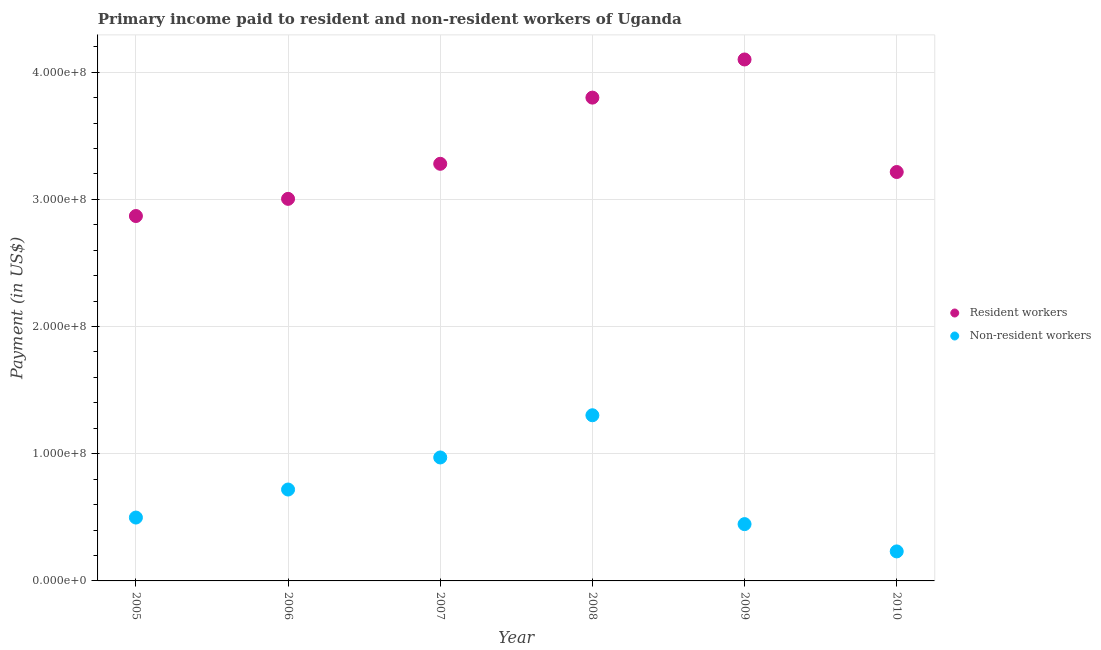How many different coloured dotlines are there?
Offer a terse response. 2. What is the payment made to resident workers in 2010?
Keep it short and to the point. 3.21e+08. Across all years, what is the maximum payment made to non-resident workers?
Give a very brief answer. 1.30e+08. Across all years, what is the minimum payment made to resident workers?
Provide a short and direct response. 2.87e+08. In which year was the payment made to resident workers maximum?
Offer a very short reply. 2009. In which year was the payment made to non-resident workers minimum?
Keep it short and to the point. 2010. What is the total payment made to resident workers in the graph?
Give a very brief answer. 2.03e+09. What is the difference between the payment made to resident workers in 2007 and that in 2009?
Your answer should be compact. -8.20e+07. What is the difference between the payment made to resident workers in 2010 and the payment made to non-resident workers in 2006?
Keep it short and to the point. 2.50e+08. What is the average payment made to resident workers per year?
Your answer should be compact. 3.38e+08. In the year 2009, what is the difference between the payment made to non-resident workers and payment made to resident workers?
Offer a terse response. -3.65e+08. What is the ratio of the payment made to non-resident workers in 2005 to that in 2006?
Your response must be concise. 0.69. What is the difference between the highest and the second highest payment made to resident workers?
Give a very brief answer. 3.00e+07. What is the difference between the highest and the lowest payment made to non-resident workers?
Give a very brief answer. 1.07e+08. In how many years, is the payment made to resident workers greater than the average payment made to resident workers taken over all years?
Your response must be concise. 2. How many years are there in the graph?
Your response must be concise. 6. What is the difference between two consecutive major ticks on the Y-axis?
Your answer should be very brief. 1.00e+08. Does the graph contain any zero values?
Ensure brevity in your answer.  No. Where does the legend appear in the graph?
Your answer should be very brief. Center right. How are the legend labels stacked?
Give a very brief answer. Vertical. What is the title of the graph?
Your answer should be compact. Primary income paid to resident and non-resident workers of Uganda. Does "Commercial bank branches" appear as one of the legend labels in the graph?
Offer a terse response. No. What is the label or title of the Y-axis?
Provide a short and direct response. Payment (in US$). What is the Payment (in US$) of Resident workers in 2005?
Provide a short and direct response. 2.87e+08. What is the Payment (in US$) of Non-resident workers in 2005?
Ensure brevity in your answer.  4.98e+07. What is the Payment (in US$) in Resident workers in 2006?
Make the answer very short. 3.00e+08. What is the Payment (in US$) of Non-resident workers in 2006?
Provide a short and direct response. 7.19e+07. What is the Payment (in US$) of Resident workers in 2007?
Make the answer very short. 3.28e+08. What is the Payment (in US$) in Non-resident workers in 2007?
Offer a very short reply. 9.71e+07. What is the Payment (in US$) of Resident workers in 2008?
Provide a short and direct response. 3.80e+08. What is the Payment (in US$) in Non-resident workers in 2008?
Ensure brevity in your answer.  1.30e+08. What is the Payment (in US$) in Resident workers in 2009?
Your answer should be very brief. 4.10e+08. What is the Payment (in US$) in Non-resident workers in 2009?
Offer a very short reply. 4.47e+07. What is the Payment (in US$) of Resident workers in 2010?
Ensure brevity in your answer.  3.21e+08. What is the Payment (in US$) in Non-resident workers in 2010?
Keep it short and to the point. 2.32e+07. Across all years, what is the maximum Payment (in US$) in Resident workers?
Keep it short and to the point. 4.10e+08. Across all years, what is the maximum Payment (in US$) of Non-resident workers?
Offer a very short reply. 1.30e+08. Across all years, what is the minimum Payment (in US$) of Resident workers?
Your answer should be very brief. 2.87e+08. Across all years, what is the minimum Payment (in US$) in Non-resident workers?
Ensure brevity in your answer.  2.32e+07. What is the total Payment (in US$) in Resident workers in the graph?
Your answer should be very brief. 2.03e+09. What is the total Payment (in US$) in Non-resident workers in the graph?
Your answer should be very brief. 4.17e+08. What is the difference between the Payment (in US$) of Resident workers in 2005 and that in 2006?
Provide a short and direct response. -1.35e+07. What is the difference between the Payment (in US$) of Non-resident workers in 2005 and that in 2006?
Your answer should be compact. -2.20e+07. What is the difference between the Payment (in US$) of Resident workers in 2005 and that in 2007?
Offer a terse response. -4.11e+07. What is the difference between the Payment (in US$) of Non-resident workers in 2005 and that in 2007?
Keep it short and to the point. -4.72e+07. What is the difference between the Payment (in US$) in Resident workers in 2005 and that in 2008?
Make the answer very short. -9.31e+07. What is the difference between the Payment (in US$) of Non-resident workers in 2005 and that in 2008?
Ensure brevity in your answer.  -8.04e+07. What is the difference between the Payment (in US$) in Resident workers in 2005 and that in 2009?
Offer a very short reply. -1.23e+08. What is the difference between the Payment (in US$) of Non-resident workers in 2005 and that in 2009?
Make the answer very short. 5.16e+06. What is the difference between the Payment (in US$) in Resident workers in 2005 and that in 2010?
Offer a terse response. -3.46e+07. What is the difference between the Payment (in US$) in Non-resident workers in 2005 and that in 2010?
Provide a short and direct response. 2.66e+07. What is the difference between the Payment (in US$) in Resident workers in 2006 and that in 2007?
Your answer should be very brief. -2.76e+07. What is the difference between the Payment (in US$) in Non-resident workers in 2006 and that in 2007?
Your response must be concise. -2.52e+07. What is the difference between the Payment (in US$) of Resident workers in 2006 and that in 2008?
Provide a short and direct response. -7.96e+07. What is the difference between the Payment (in US$) in Non-resident workers in 2006 and that in 2008?
Offer a very short reply. -5.84e+07. What is the difference between the Payment (in US$) in Resident workers in 2006 and that in 2009?
Give a very brief answer. -1.10e+08. What is the difference between the Payment (in US$) of Non-resident workers in 2006 and that in 2009?
Give a very brief answer. 2.72e+07. What is the difference between the Payment (in US$) in Resident workers in 2006 and that in 2010?
Give a very brief answer. -2.11e+07. What is the difference between the Payment (in US$) in Non-resident workers in 2006 and that in 2010?
Provide a short and direct response. 4.86e+07. What is the difference between the Payment (in US$) in Resident workers in 2007 and that in 2008?
Provide a succinct answer. -5.20e+07. What is the difference between the Payment (in US$) of Non-resident workers in 2007 and that in 2008?
Offer a terse response. -3.32e+07. What is the difference between the Payment (in US$) in Resident workers in 2007 and that in 2009?
Provide a short and direct response. -8.20e+07. What is the difference between the Payment (in US$) of Non-resident workers in 2007 and that in 2009?
Your answer should be very brief. 5.24e+07. What is the difference between the Payment (in US$) of Resident workers in 2007 and that in 2010?
Your response must be concise. 6.45e+06. What is the difference between the Payment (in US$) of Non-resident workers in 2007 and that in 2010?
Your answer should be very brief. 7.39e+07. What is the difference between the Payment (in US$) of Resident workers in 2008 and that in 2009?
Provide a succinct answer. -3.00e+07. What is the difference between the Payment (in US$) in Non-resident workers in 2008 and that in 2009?
Your answer should be compact. 8.56e+07. What is the difference between the Payment (in US$) of Resident workers in 2008 and that in 2010?
Keep it short and to the point. 5.85e+07. What is the difference between the Payment (in US$) in Non-resident workers in 2008 and that in 2010?
Provide a short and direct response. 1.07e+08. What is the difference between the Payment (in US$) in Resident workers in 2009 and that in 2010?
Your response must be concise. 8.85e+07. What is the difference between the Payment (in US$) in Non-resident workers in 2009 and that in 2010?
Ensure brevity in your answer.  2.15e+07. What is the difference between the Payment (in US$) in Resident workers in 2005 and the Payment (in US$) in Non-resident workers in 2006?
Give a very brief answer. 2.15e+08. What is the difference between the Payment (in US$) of Resident workers in 2005 and the Payment (in US$) of Non-resident workers in 2007?
Ensure brevity in your answer.  1.90e+08. What is the difference between the Payment (in US$) in Resident workers in 2005 and the Payment (in US$) in Non-resident workers in 2008?
Provide a succinct answer. 1.57e+08. What is the difference between the Payment (in US$) in Resident workers in 2005 and the Payment (in US$) in Non-resident workers in 2009?
Ensure brevity in your answer.  2.42e+08. What is the difference between the Payment (in US$) in Resident workers in 2005 and the Payment (in US$) in Non-resident workers in 2010?
Your answer should be very brief. 2.64e+08. What is the difference between the Payment (in US$) in Resident workers in 2006 and the Payment (in US$) in Non-resident workers in 2007?
Give a very brief answer. 2.03e+08. What is the difference between the Payment (in US$) in Resident workers in 2006 and the Payment (in US$) in Non-resident workers in 2008?
Provide a short and direct response. 1.70e+08. What is the difference between the Payment (in US$) in Resident workers in 2006 and the Payment (in US$) in Non-resident workers in 2009?
Your answer should be very brief. 2.56e+08. What is the difference between the Payment (in US$) of Resident workers in 2006 and the Payment (in US$) of Non-resident workers in 2010?
Your answer should be compact. 2.77e+08. What is the difference between the Payment (in US$) of Resident workers in 2007 and the Payment (in US$) of Non-resident workers in 2008?
Provide a succinct answer. 1.98e+08. What is the difference between the Payment (in US$) of Resident workers in 2007 and the Payment (in US$) of Non-resident workers in 2009?
Provide a succinct answer. 2.83e+08. What is the difference between the Payment (in US$) of Resident workers in 2007 and the Payment (in US$) of Non-resident workers in 2010?
Provide a short and direct response. 3.05e+08. What is the difference between the Payment (in US$) in Resident workers in 2008 and the Payment (in US$) in Non-resident workers in 2009?
Offer a terse response. 3.35e+08. What is the difference between the Payment (in US$) in Resident workers in 2008 and the Payment (in US$) in Non-resident workers in 2010?
Provide a succinct answer. 3.57e+08. What is the difference between the Payment (in US$) of Resident workers in 2009 and the Payment (in US$) of Non-resident workers in 2010?
Offer a terse response. 3.87e+08. What is the average Payment (in US$) in Resident workers per year?
Offer a very short reply. 3.38e+08. What is the average Payment (in US$) of Non-resident workers per year?
Provide a succinct answer. 6.95e+07. In the year 2005, what is the difference between the Payment (in US$) of Resident workers and Payment (in US$) of Non-resident workers?
Offer a terse response. 2.37e+08. In the year 2006, what is the difference between the Payment (in US$) of Resident workers and Payment (in US$) of Non-resident workers?
Ensure brevity in your answer.  2.29e+08. In the year 2007, what is the difference between the Payment (in US$) of Resident workers and Payment (in US$) of Non-resident workers?
Make the answer very short. 2.31e+08. In the year 2008, what is the difference between the Payment (in US$) of Resident workers and Payment (in US$) of Non-resident workers?
Provide a short and direct response. 2.50e+08. In the year 2009, what is the difference between the Payment (in US$) of Resident workers and Payment (in US$) of Non-resident workers?
Provide a succinct answer. 3.65e+08. In the year 2010, what is the difference between the Payment (in US$) in Resident workers and Payment (in US$) in Non-resident workers?
Your response must be concise. 2.98e+08. What is the ratio of the Payment (in US$) of Resident workers in 2005 to that in 2006?
Keep it short and to the point. 0.96. What is the ratio of the Payment (in US$) of Non-resident workers in 2005 to that in 2006?
Make the answer very short. 0.69. What is the ratio of the Payment (in US$) of Resident workers in 2005 to that in 2007?
Your answer should be very brief. 0.87. What is the ratio of the Payment (in US$) in Non-resident workers in 2005 to that in 2007?
Make the answer very short. 0.51. What is the ratio of the Payment (in US$) of Resident workers in 2005 to that in 2008?
Give a very brief answer. 0.76. What is the ratio of the Payment (in US$) in Non-resident workers in 2005 to that in 2008?
Your answer should be very brief. 0.38. What is the ratio of the Payment (in US$) of Resident workers in 2005 to that in 2009?
Provide a short and direct response. 0.7. What is the ratio of the Payment (in US$) of Non-resident workers in 2005 to that in 2009?
Keep it short and to the point. 1.12. What is the ratio of the Payment (in US$) of Resident workers in 2005 to that in 2010?
Offer a very short reply. 0.89. What is the ratio of the Payment (in US$) of Non-resident workers in 2005 to that in 2010?
Provide a short and direct response. 2.15. What is the ratio of the Payment (in US$) in Resident workers in 2006 to that in 2007?
Your answer should be compact. 0.92. What is the ratio of the Payment (in US$) of Non-resident workers in 2006 to that in 2007?
Your answer should be compact. 0.74. What is the ratio of the Payment (in US$) of Resident workers in 2006 to that in 2008?
Offer a terse response. 0.79. What is the ratio of the Payment (in US$) in Non-resident workers in 2006 to that in 2008?
Keep it short and to the point. 0.55. What is the ratio of the Payment (in US$) of Resident workers in 2006 to that in 2009?
Make the answer very short. 0.73. What is the ratio of the Payment (in US$) of Non-resident workers in 2006 to that in 2009?
Keep it short and to the point. 1.61. What is the ratio of the Payment (in US$) of Resident workers in 2006 to that in 2010?
Make the answer very short. 0.93. What is the ratio of the Payment (in US$) of Non-resident workers in 2006 to that in 2010?
Keep it short and to the point. 3.1. What is the ratio of the Payment (in US$) of Resident workers in 2007 to that in 2008?
Give a very brief answer. 0.86. What is the ratio of the Payment (in US$) of Non-resident workers in 2007 to that in 2008?
Provide a short and direct response. 0.75. What is the ratio of the Payment (in US$) in Resident workers in 2007 to that in 2009?
Provide a short and direct response. 0.8. What is the ratio of the Payment (in US$) in Non-resident workers in 2007 to that in 2009?
Offer a very short reply. 2.17. What is the ratio of the Payment (in US$) of Resident workers in 2007 to that in 2010?
Your answer should be very brief. 1.02. What is the ratio of the Payment (in US$) in Non-resident workers in 2007 to that in 2010?
Make the answer very short. 4.18. What is the ratio of the Payment (in US$) of Resident workers in 2008 to that in 2009?
Your answer should be compact. 0.93. What is the ratio of the Payment (in US$) of Non-resident workers in 2008 to that in 2009?
Provide a succinct answer. 2.92. What is the ratio of the Payment (in US$) in Resident workers in 2008 to that in 2010?
Your answer should be very brief. 1.18. What is the ratio of the Payment (in US$) of Non-resident workers in 2008 to that in 2010?
Your answer should be compact. 5.61. What is the ratio of the Payment (in US$) of Resident workers in 2009 to that in 2010?
Give a very brief answer. 1.28. What is the ratio of the Payment (in US$) in Non-resident workers in 2009 to that in 2010?
Provide a short and direct response. 1.92. What is the difference between the highest and the second highest Payment (in US$) in Resident workers?
Your response must be concise. 3.00e+07. What is the difference between the highest and the second highest Payment (in US$) of Non-resident workers?
Provide a succinct answer. 3.32e+07. What is the difference between the highest and the lowest Payment (in US$) in Resident workers?
Keep it short and to the point. 1.23e+08. What is the difference between the highest and the lowest Payment (in US$) in Non-resident workers?
Make the answer very short. 1.07e+08. 